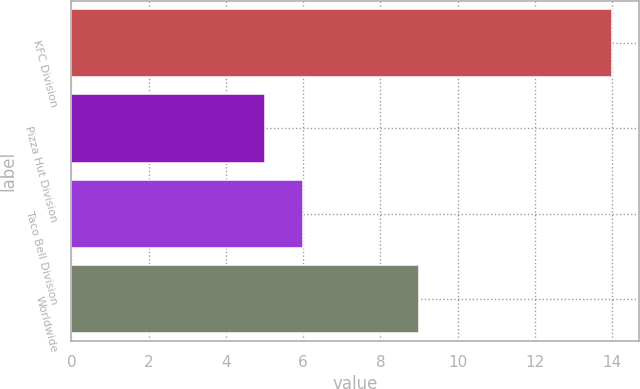Convert chart to OTSL. <chart><loc_0><loc_0><loc_500><loc_500><bar_chart><fcel>KFC Division<fcel>Pizza Hut Division<fcel>Taco Bell Division<fcel>Worldwide<nl><fcel>14<fcel>5<fcel>6<fcel>9<nl></chart> 